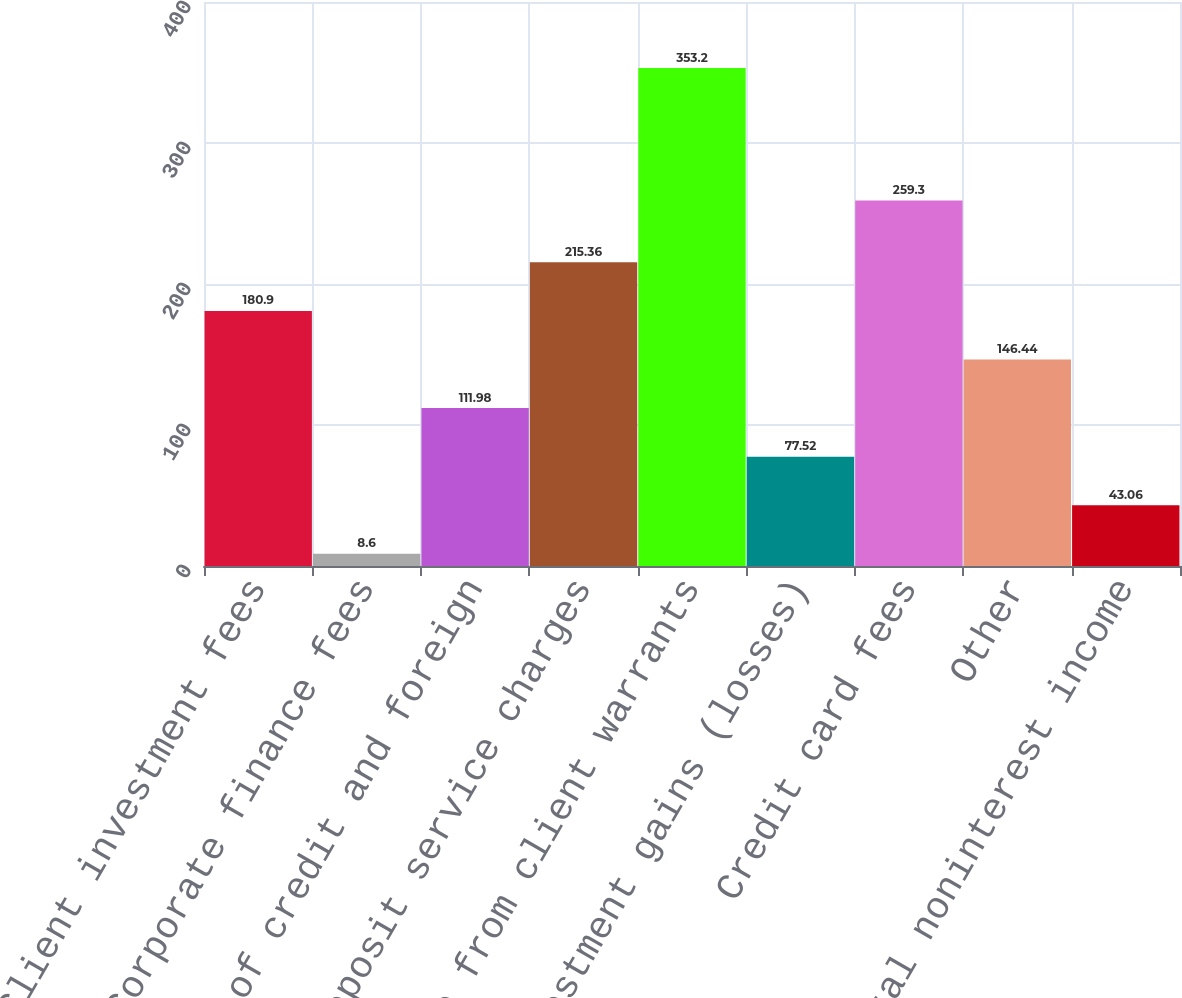<chart> <loc_0><loc_0><loc_500><loc_500><bar_chart><fcel>Client investment fees<fcel>Corporate finance fees<fcel>Letter of credit and foreign<fcel>Deposit service charges<fcel>Income from client warrants<fcel>Investment gains (losses)<fcel>Credit card fees<fcel>Other<fcel>Total noninterest income<nl><fcel>180.9<fcel>8.6<fcel>111.98<fcel>215.36<fcel>353.2<fcel>77.52<fcel>259.3<fcel>146.44<fcel>43.06<nl></chart> 